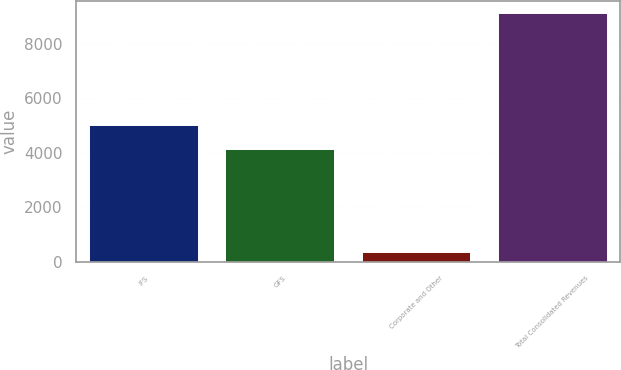Convert chart to OTSL. <chart><loc_0><loc_0><loc_500><loc_500><bar_chart><fcel>IFS<fcel>GFS<fcel>Corporate and Other<fcel>Total Consolidated Revenues<nl><fcel>5014.8<fcel>4138<fcel>355<fcel>9123<nl></chart> 